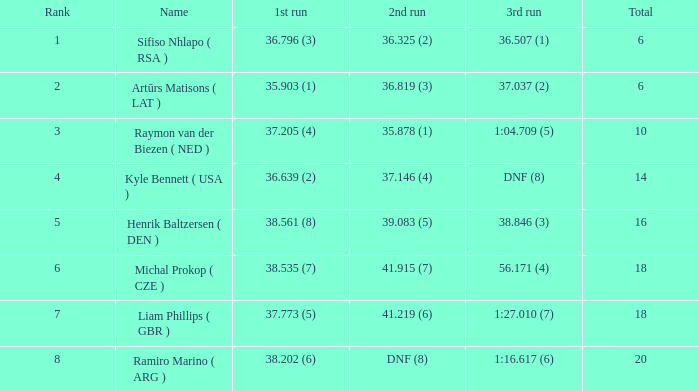Which 3rd run has rank of 8? 1:16.617 (6). 